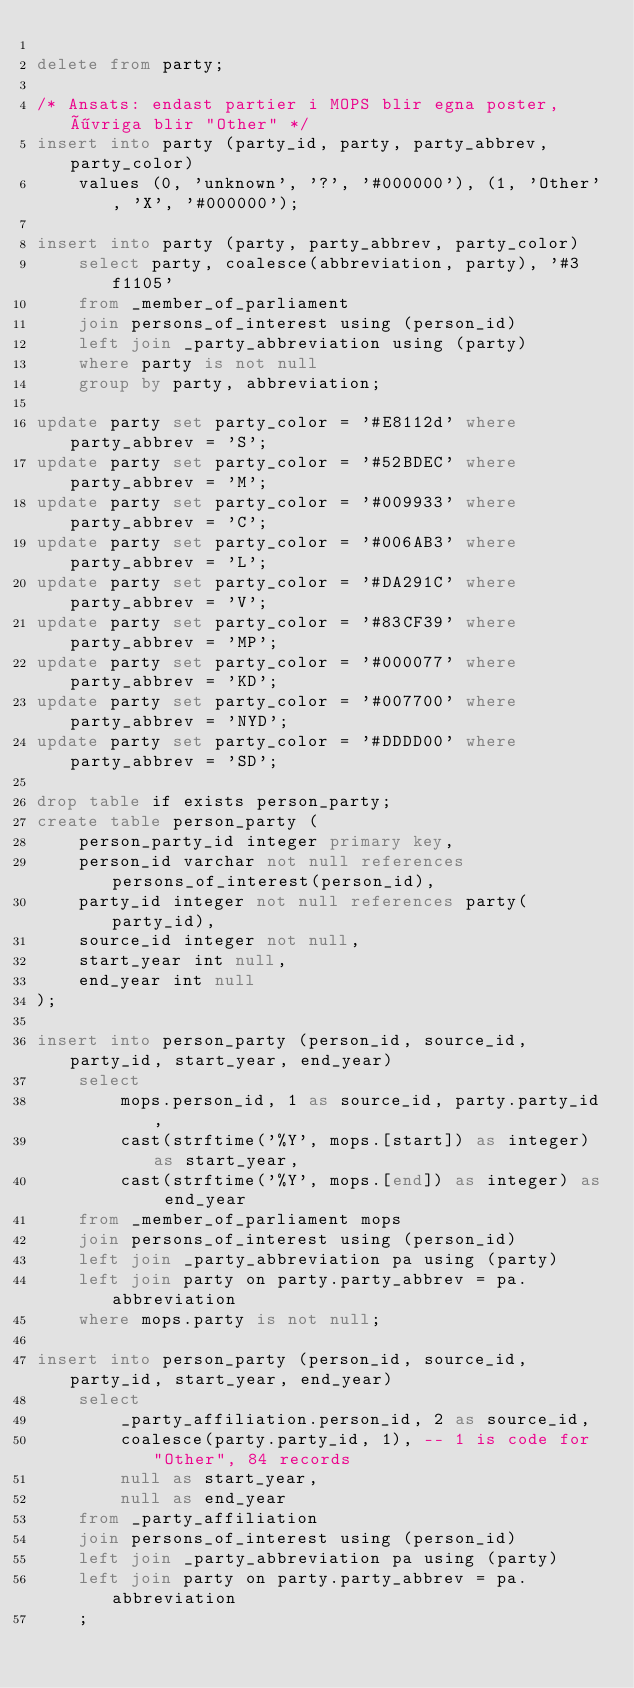Convert code to text. <code><loc_0><loc_0><loc_500><loc_500><_SQL_>
delete from party;

/* Ansats: endast partier i MOPS blir egna poster, övriga blir "Other" */
insert into party (party_id, party, party_abbrev, party_color)
    values (0, 'unknown', '?', '#000000'), (1, 'Other', 'X', '#000000');

insert into party (party, party_abbrev, party_color)
    select party, coalesce(abbreviation, party), '#3f1105'
    from _member_of_parliament
    join persons_of_interest using (person_id)
    left join _party_abbreviation using (party)
    where party is not null
    group by party, abbreviation;

update party set party_color = '#E8112d' where party_abbrev = 'S';
update party set party_color = '#52BDEC' where party_abbrev = 'M';
update party set party_color = '#009933' where party_abbrev = 'C';
update party set party_color = '#006AB3' where party_abbrev = 'L';
update party set party_color = '#DA291C' where party_abbrev = 'V';
update party set party_color = '#83CF39' where party_abbrev = 'MP';
update party set party_color = '#000077' where party_abbrev = 'KD';
update party set party_color = '#007700' where party_abbrev = 'NYD';
update party set party_color = '#DDDD00' where party_abbrev = 'SD';

drop table if exists person_party;
create table person_party (
    person_party_id integer primary key,
    person_id varchar not null references persons_of_interest(person_id),
    party_id integer not null references party(party_id),
    source_id integer not null,
    start_year int null,
    end_year int null
);

insert into person_party (person_id, source_id, party_id, start_year, end_year)
    select
        mops.person_id, 1 as source_id, party.party_id,
        cast(strftime('%Y', mops.[start]) as integer) as start_year,
        cast(strftime('%Y', mops.[end]) as integer) as end_year
    from _member_of_parliament mops
    join persons_of_interest using (person_id)
    left join _party_abbreviation pa using (party)
    left join party on party.party_abbrev = pa.abbreviation
    where mops.party is not null;

insert into person_party (person_id, source_id, party_id, start_year, end_year)
    select
        _party_affiliation.person_id, 2 as source_id,
        coalesce(party.party_id, 1), -- 1 is code for "Other", 84 records
        null as start_year,
        null as end_year
    from _party_affiliation
    join persons_of_interest using (person_id)
    left join _party_abbreviation pa using (party)
    left join party on party.party_abbrev = pa.abbreviation
    ;
</code> 